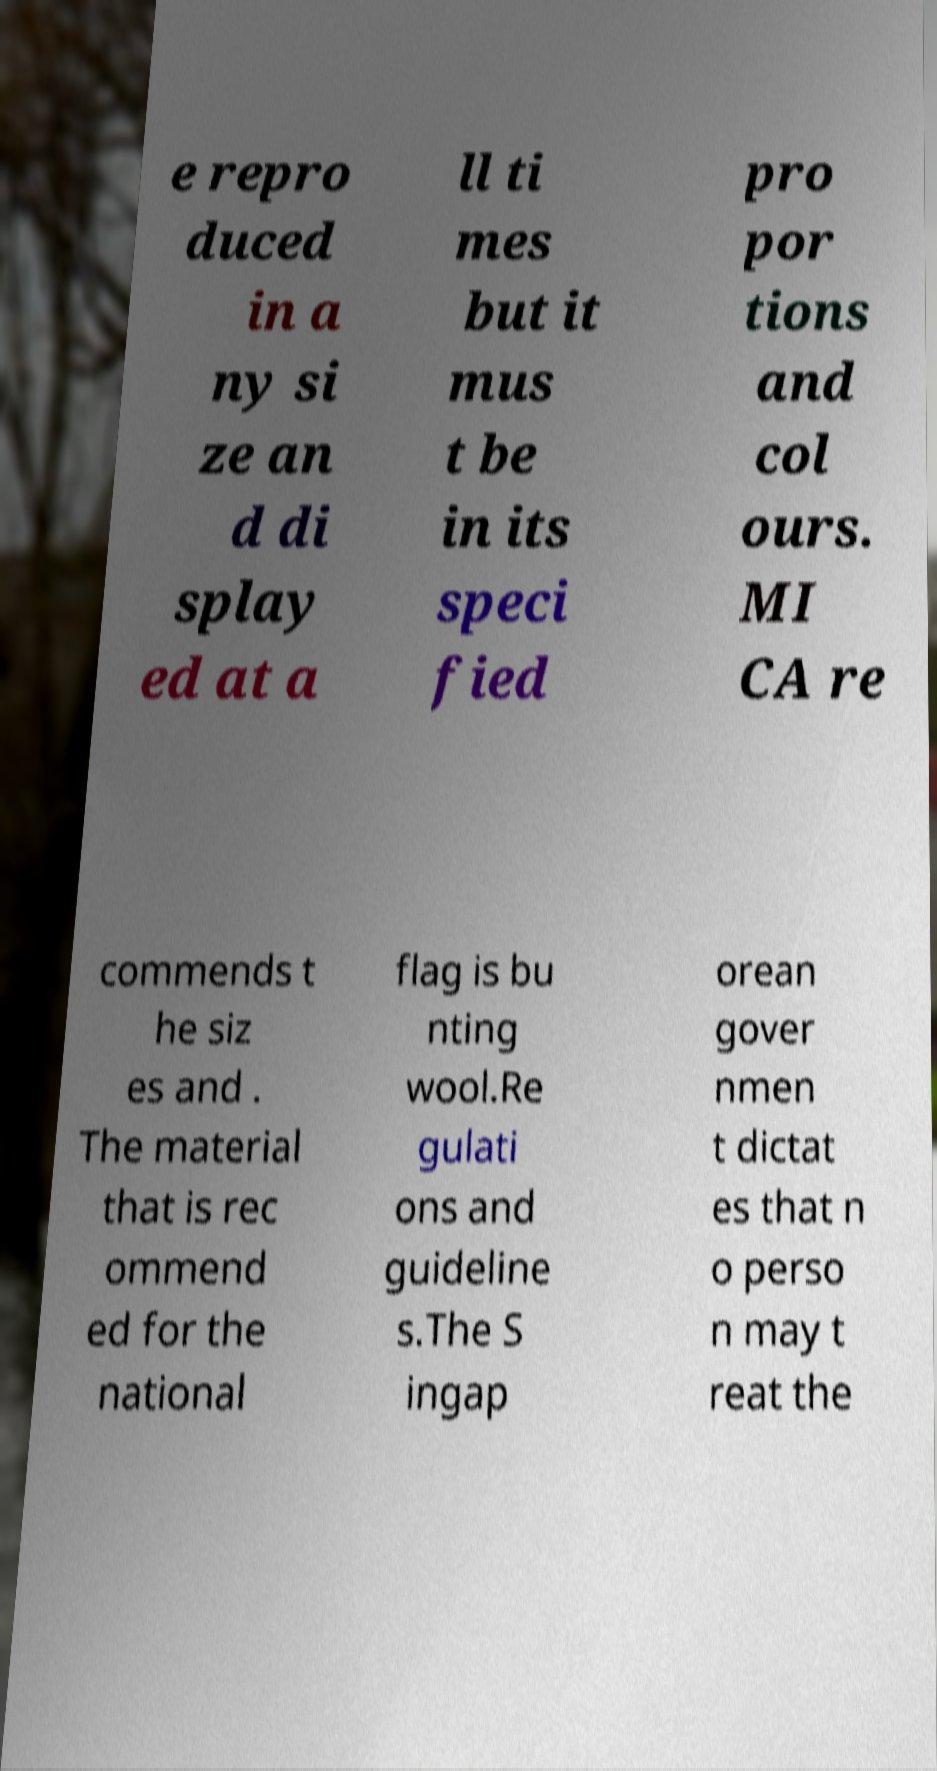Please identify and transcribe the text found in this image. e repro duced in a ny si ze an d di splay ed at a ll ti mes but it mus t be in its speci fied pro por tions and col ours. MI CA re commends t he siz es and . The material that is rec ommend ed for the national flag is bu nting wool.Re gulati ons and guideline s.The S ingap orean gover nmen t dictat es that n o perso n may t reat the 